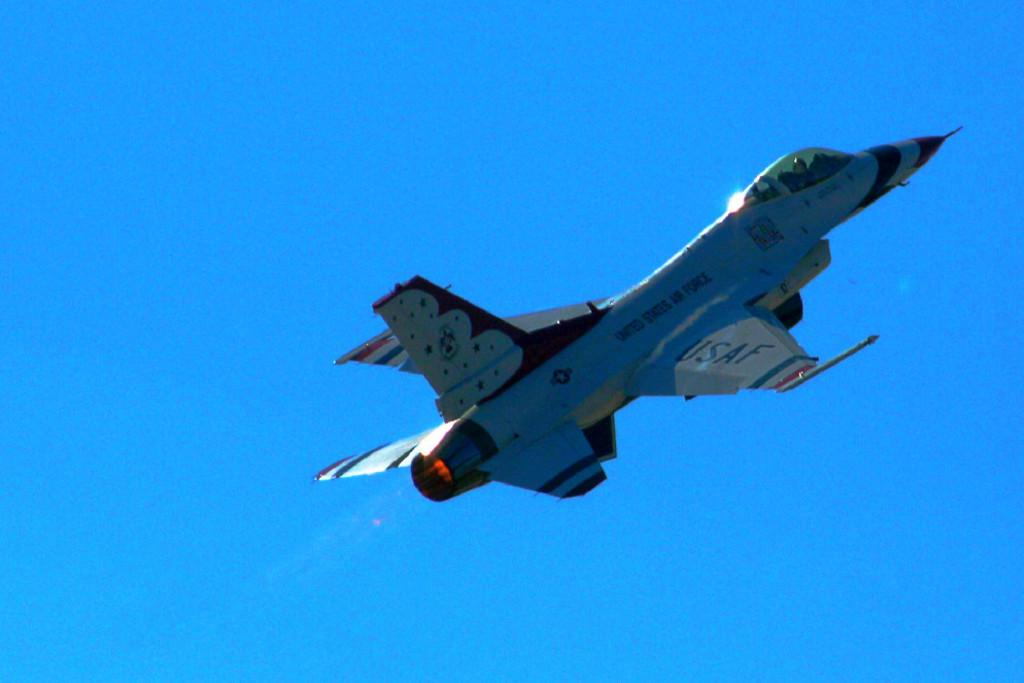<image>
Create a compact narrative representing the image presented. a United States Air Force or USAF military jet shooting in the sky 